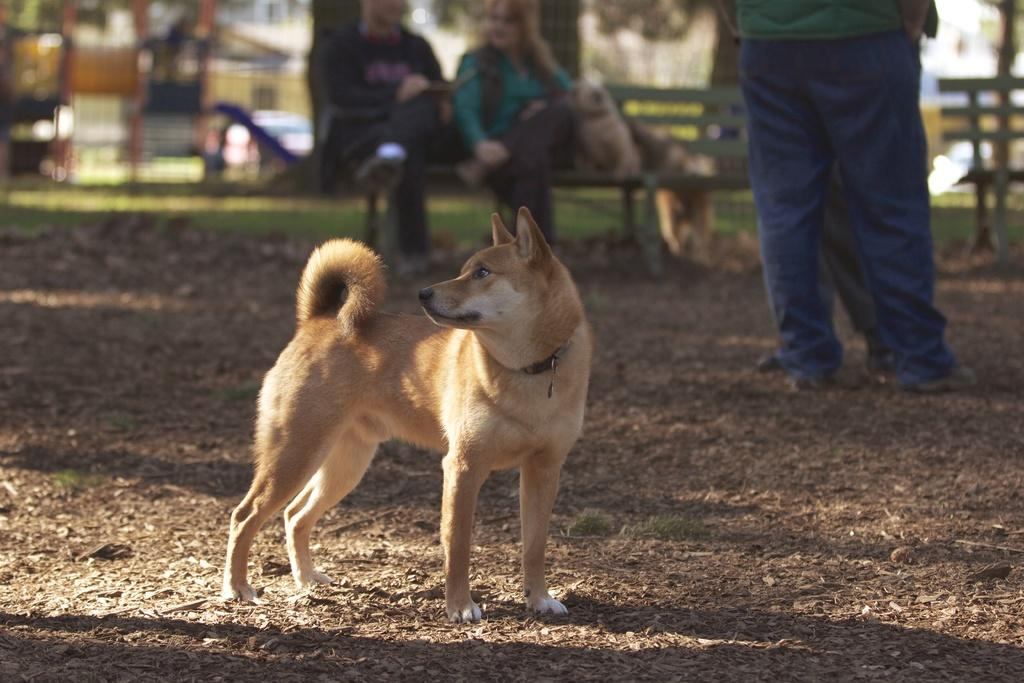What type of animal can be seen in the image? There is a dog in the image. How many people are standing in the image? There are two persons standing on the ground. What are the people in the background doing? There are two persons sitting on a bench in the background. What can be seen in the background of the image? Trees and a car are visible in the background. What type of sidewalk can be seen in the image? There is no sidewalk present in the image. What letter is the coach holding in the image? There is no coach or letter present in the image. 